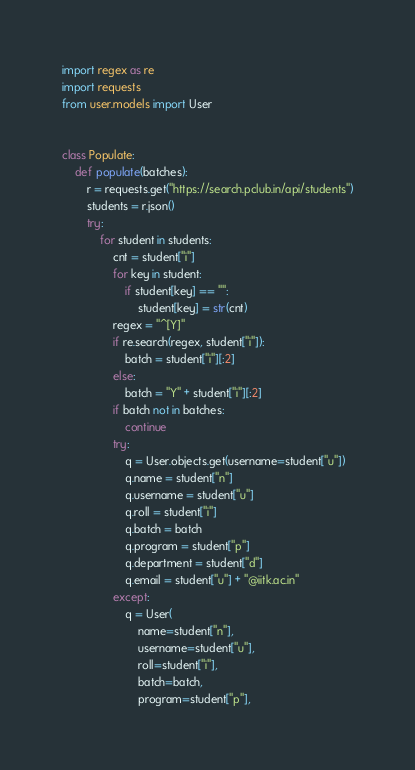Convert code to text. <code><loc_0><loc_0><loc_500><loc_500><_Python_>import regex as re
import requests
from user.models import User


class Populate:
    def populate(batches):
        r = requests.get("https://search.pclub.in/api/students")
        students = r.json()
        try:
            for student in students:
                cnt = student["i"]
                for key in student:
                    if student[key] == "":
                        student[key] = str(cnt)
                regex = "^[Y]"
                if re.search(regex, student["i"]):
                    batch = student["i"][:2]
                else:
                    batch = "Y" + student["i"][:2]
                if batch not in batches:
                    continue
                try:
                    q = User.objects.get(username=student["u"])
                    q.name = student["n"]
                    q.username = student["u"]
                    q.roll = student["i"]
                    q.batch = batch
                    q.program = student["p"]
                    q.department = student["d"]
                    q.email = student["u"] + "@iitk.ac.in"
                except:
                    q = User(
                        name=student["n"],
                        username=student["u"],
                        roll=student["i"],
                        batch=batch,
                        program=student["p"],</code> 